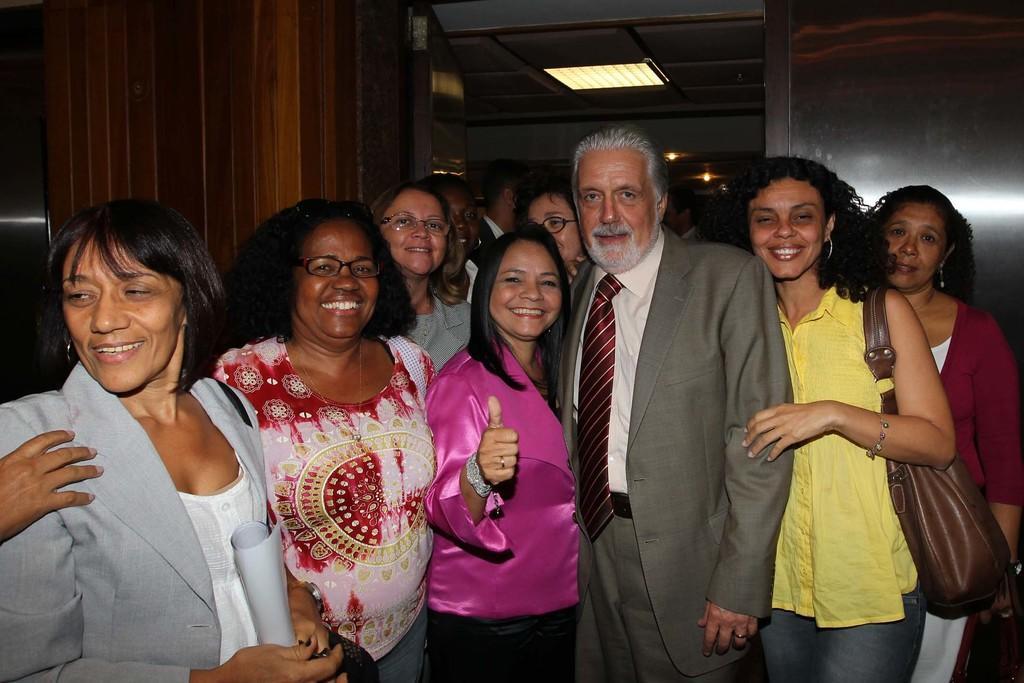How would you summarize this image in a sentence or two? In this image we can see a group of people standing. In that a woman is holding some papers. On the backside we can see a wall and a roof with some ceiling lights. 